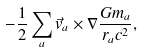<formula> <loc_0><loc_0><loc_500><loc_500>- \frac { 1 } { 2 } \sum _ { a } \vec { v } _ { a } \times \nabla \frac { G m _ { a } } { r _ { a } c ^ { 2 } } ,</formula> 